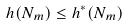Convert formula to latex. <formula><loc_0><loc_0><loc_500><loc_500>h ( N _ { m } ) \leq h ^ { * } ( N _ { m } )</formula> 